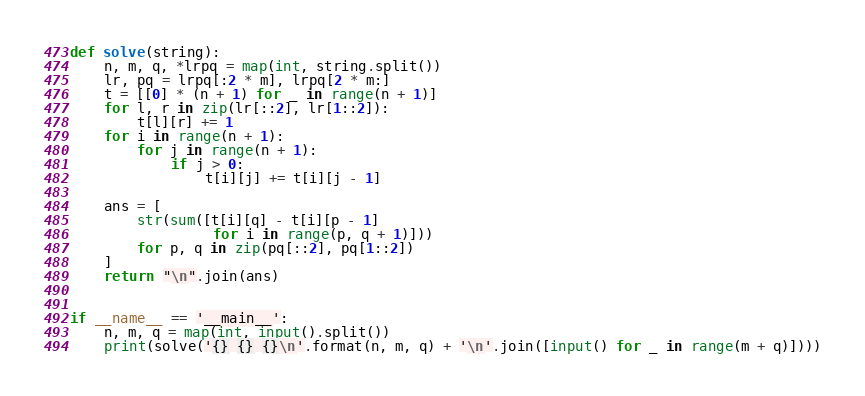<code> <loc_0><loc_0><loc_500><loc_500><_Python_>def solve(string):
    n, m, q, *lrpq = map(int, string.split())
    lr, pq = lrpq[:2 * m], lrpq[2 * m:]
    t = [[0] * (n + 1) for _ in range(n + 1)]
    for l, r in zip(lr[::2], lr[1::2]):
        t[l][r] += 1
    for i in range(n + 1):
        for j in range(n + 1):
            if j > 0:
                t[i][j] += t[i][j - 1]

    ans = [
        str(sum([t[i][q] - t[i][p - 1]
                 for i in range(p, q + 1)]))
        for p, q in zip(pq[::2], pq[1::2])
    ]
    return "\n".join(ans)


if __name__ == '__main__':
    n, m, q = map(int, input().split())
    print(solve('{} {} {}\n'.format(n, m, q) + '\n'.join([input() for _ in range(m + q)])))
</code> 